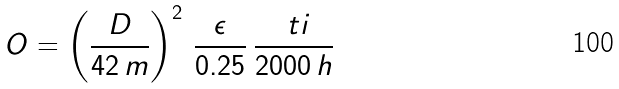Convert formula to latex. <formula><loc_0><loc_0><loc_500><loc_500>O = \left ( \frac { D } { 4 2 \, m } \right ) ^ { 2 } \, \frac { \epsilon } { 0 . 2 5 } \, \frac { \ t i } { 2 0 0 0 \, h }</formula> 